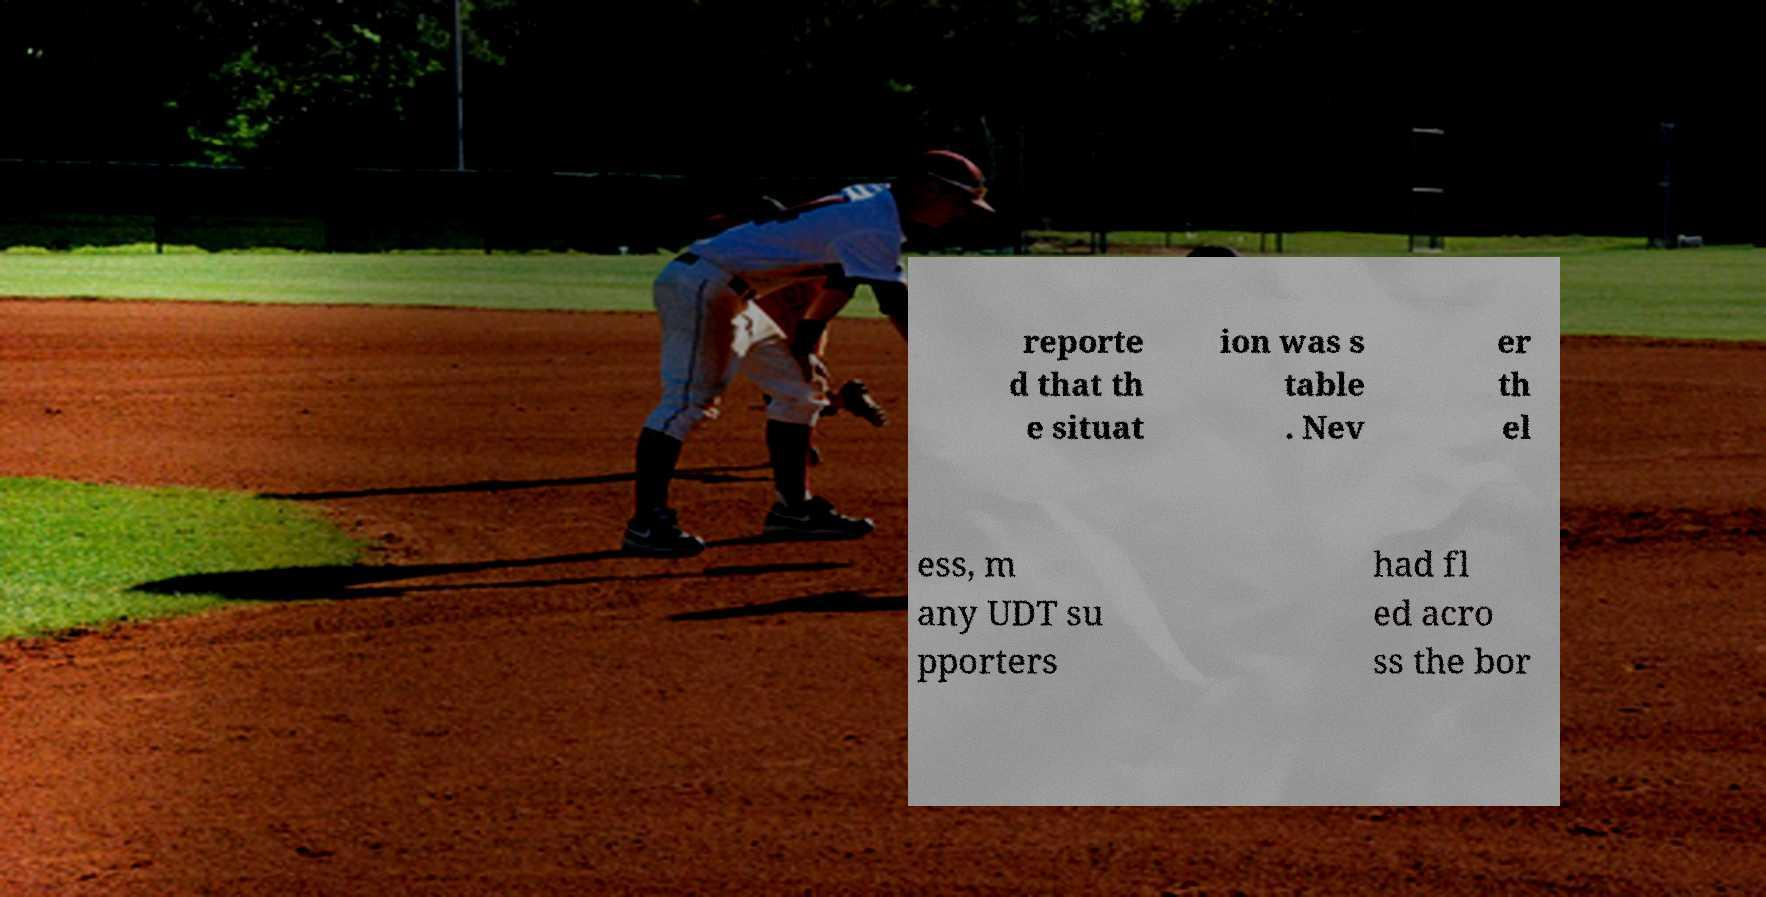Could you assist in decoding the text presented in this image and type it out clearly? reporte d that th e situat ion was s table . Nev er th el ess, m any UDT su pporters had fl ed acro ss the bor 